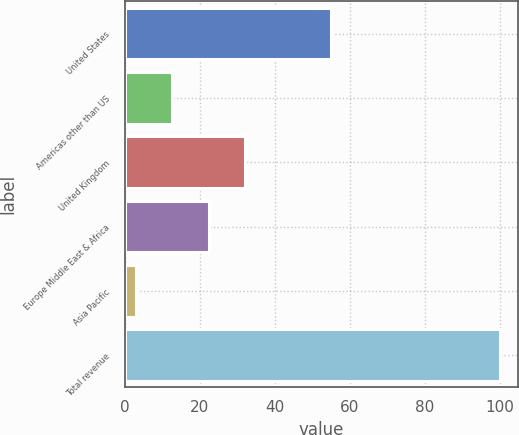<chart> <loc_0><loc_0><loc_500><loc_500><bar_chart><fcel>United States<fcel>Americas other than US<fcel>United Kingdom<fcel>Europe Middle East & Africa<fcel>Asia Pacific<fcel>Total revenue<nl><fcel>55<fcel>12.7<fcel>32.1<fcel>22.4<fcel>3<fcel>100<nl></chart> 